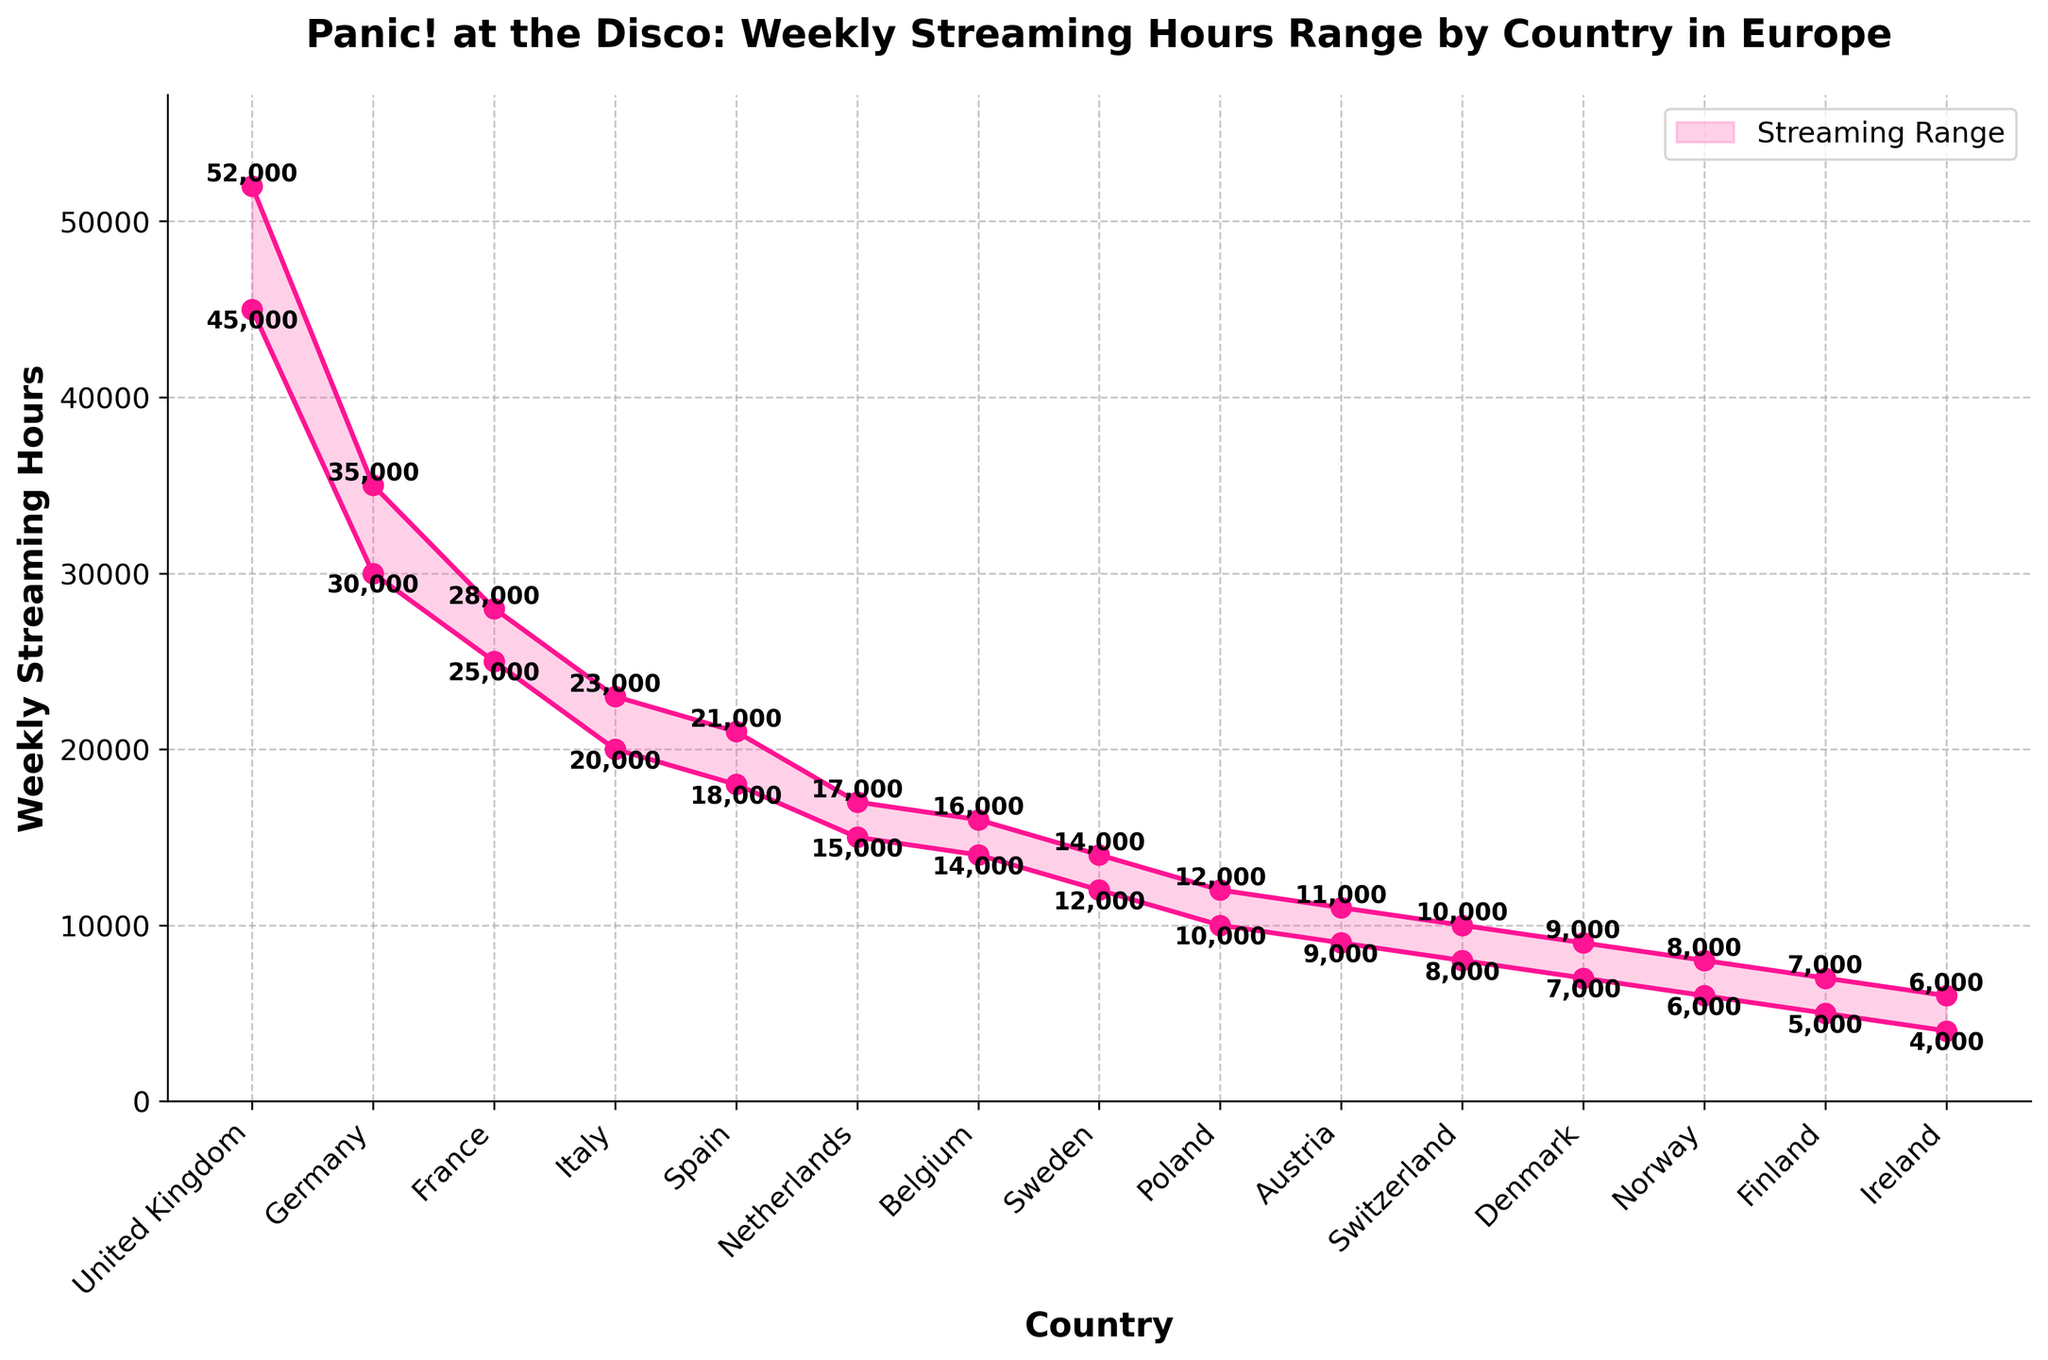Which country has the highest maximum streaming hours? The highest maximum streaming hours can be found in the plot, where the United Kingdom has the highest peak value among all the countries.
Answer: United Kingdom What is the range of streaming hours for Germany? The range is calculated by subtracting the minimum streaming hours from the maximum streaming hours for Germany, which can be observed from the figure.
Answer: 5000 Which country has the smallest difference between minimum and maximum streaming hours? To find this country, examine the plot for the country with the smallest gap between the lower and upper bounds of the shaded area.
Answer: France What is the average maximum streaming hours of the top three countries with the highest maximum streaming hours? Identify the top three countries by maximum streaming hours (United Kingdom, Germany, France), add their maximum values (52000 + 35000 + 28000), and divide by 3.
Answer: 38333.33 How many countries have a minimum streaming hour range below 10,000? Count the number of countries in the plot where the minimum streaming hours' points are below 10,000. These countries are Switzerland, Denmark, Norway, Finland, and Ireland.
Answer: 5 Compare the minimum streaming hours between Italy and Spain. What is the difference? Subtract the minimum streaming hours of Spain from those of Italy (20000 - 18000).
Answer: 2000 Which country shows the highest consistency in streaming hours (smallest range)? Examine the plot for the smallest range between minimum and maximum streams. France has the smallest range (28000 - 25000).
Answer: France Looking at the plot, what is the streaming range for the Netherlands? Identify the lower and upper bounds for the Netherlands' shaded area and subtract the minimum from the maximum (17000 - 15000).
Answer: 2000 Which three countries have the lowest maximum streaming hours, and what are their values? Identify the three countries with the lowest peaks in the plot: Finland, Ireland, and Norway. Their maximum values are 7000, 6000, and 8000 respectively.
Answer: Finland: 7000, Ireland: 6000, Norway: 8000 How does the range of streaming hours in Sweden compare to that of Poland? Calculate and compare the ranges by subtracting the minimum streaming hours from the maximum for each country (Sweden: 14000 - 12000, Poland: 12000 - 10000).
Answer: Sweden: 2000, Poland: 2000 